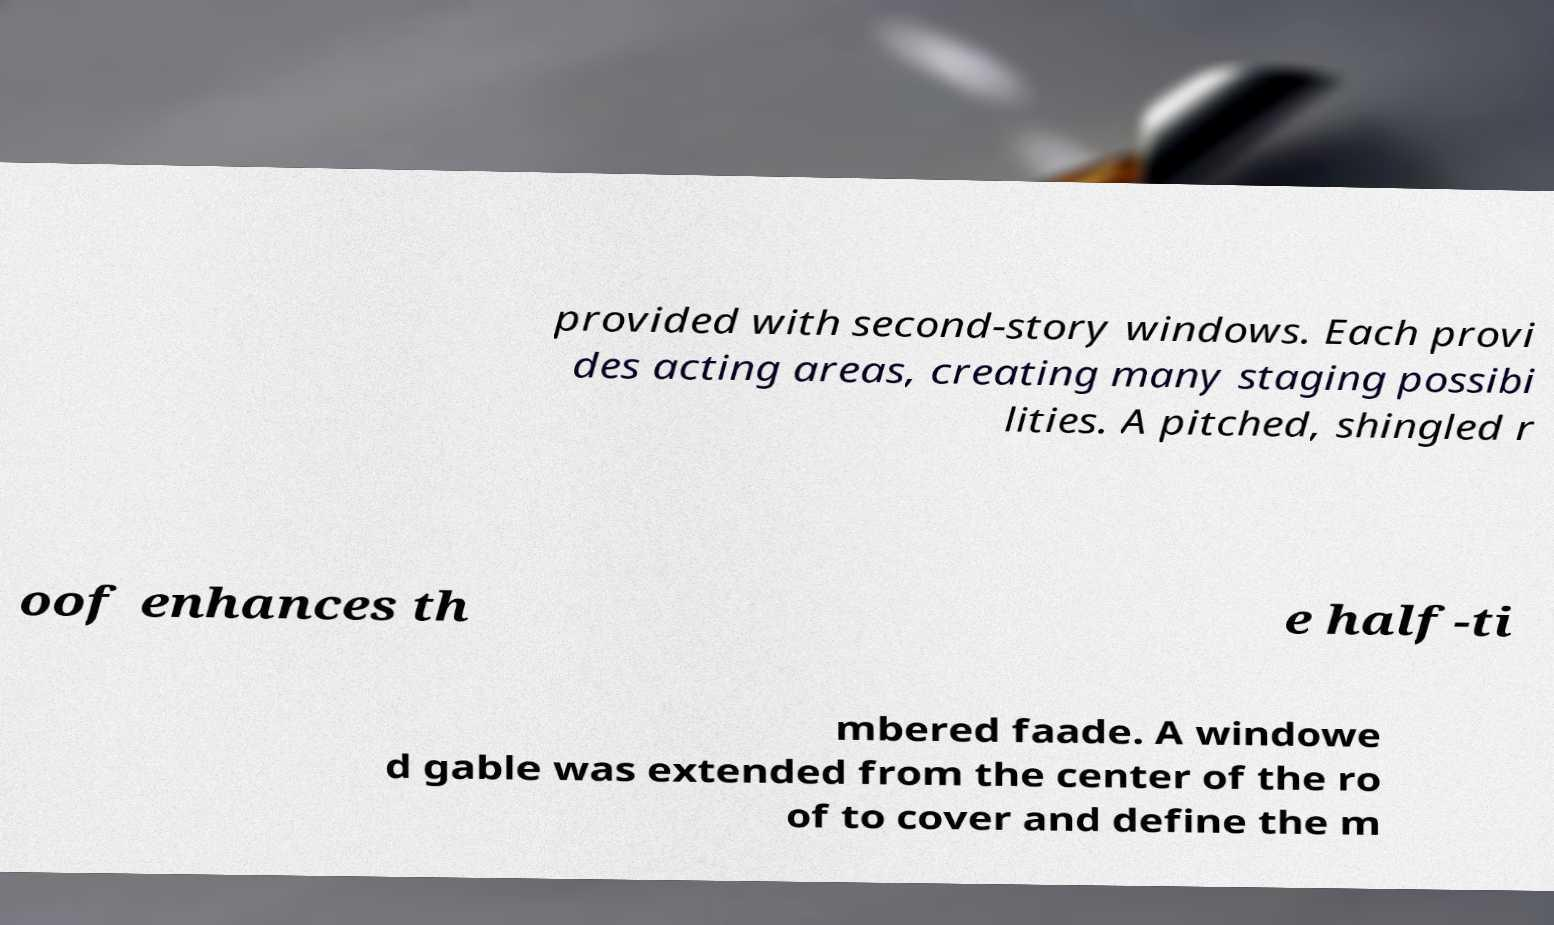Please read and relay the text visible in this image. What does it say? provided with second-story windows. Each provi des acting areas, creating many staging possibi lities. A pitched, shingled r oof enhances th e half-ti mbered faade. A windowe d gable was extended from the center of the ro of to cover and define the m 